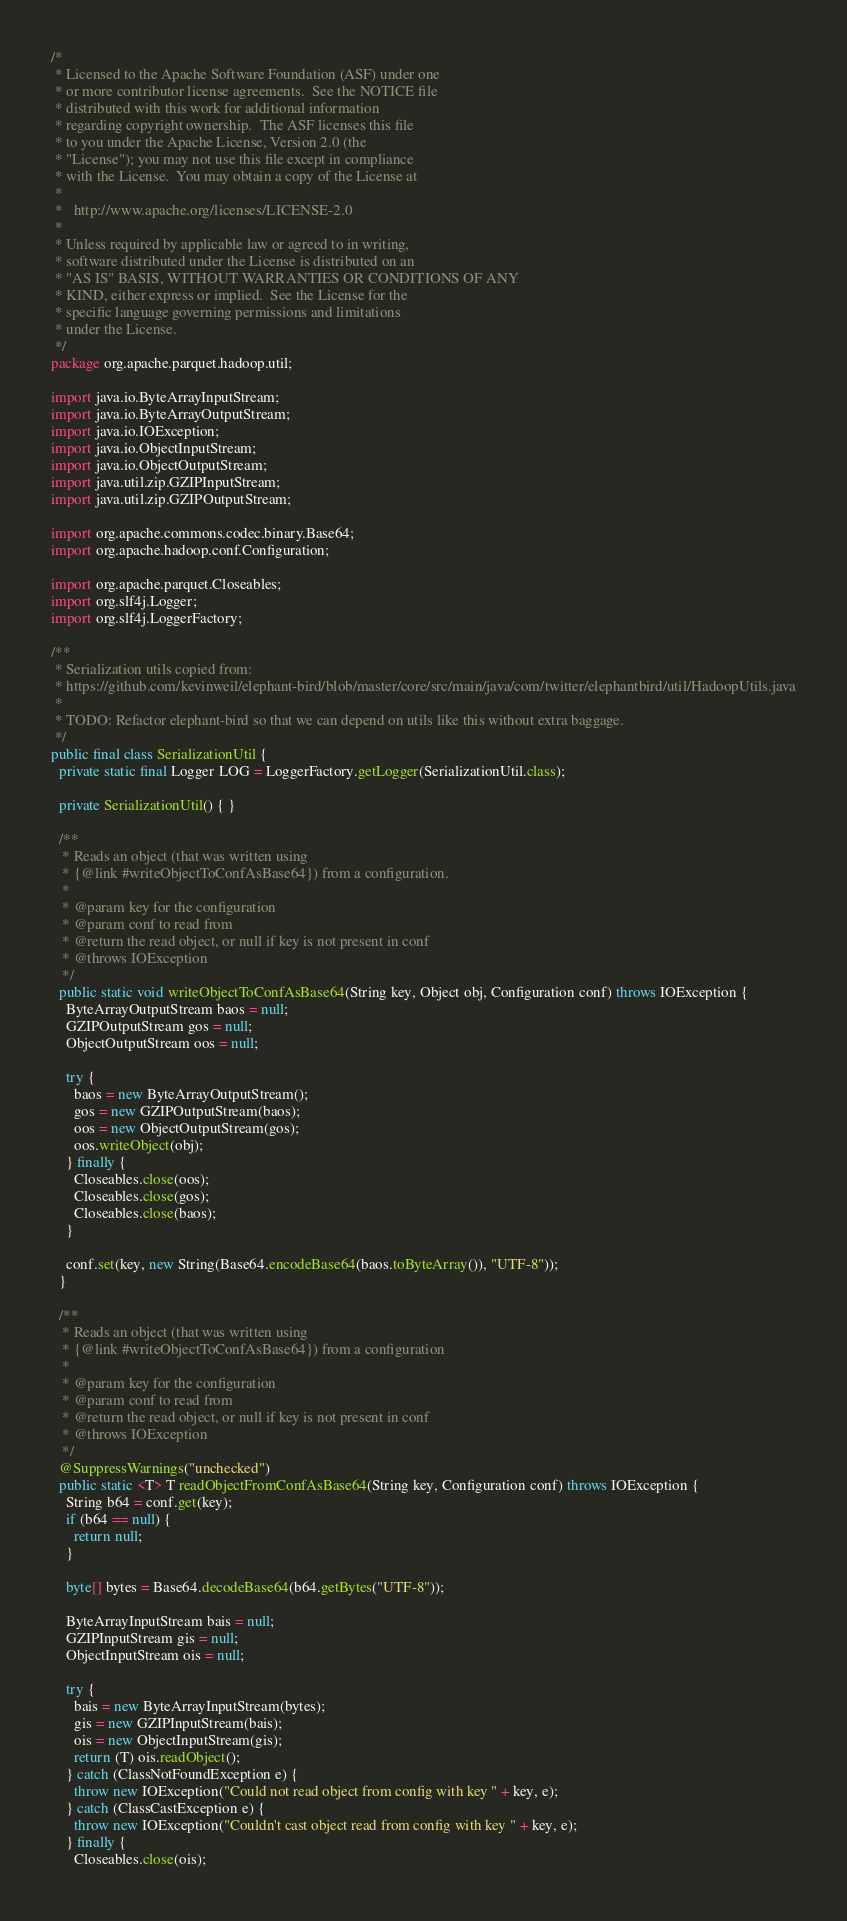Convert code to text. <code><loc_0><loc_0><loc_500><loc_500><_Java_>/* 
 * Licensed to the Apache Software Foundation (ASF) under one
 * or more contributor license agreements.  See the NOTICE file
 * distributed with this work for additional information
 * regarding copyright ownership.  The ASF licenses this file
 * to you under the Apache License, Version 2.0 (the
 * "License"); you may not use this file except in compliance
 * with the License.  You may obtain a copy of the License at
 * 
 *   http://www.apache.org/licenses/LICENSE-2.0
 * 
 * Unless required by applicable law or agreed to in writing,
 * software distributed under the License is distributed on an
 * "AS IS" BASIS, WITHOUT WARRANTIES OR CONDITIONS OF ANY
 * KIND, either express or implied.  See the License for the
 * specific language governing permissions and limitations
 * under the License.
 */
package org.apache.parquet.hadoop.util;

import java.io.ByteArrayInputStream;
import java.io.ByteArrayOutputStream;
import java.io.IOException;
import java.io.ObjectInputStream;
import java.io.ObjectOutputStream;
import java.util.zip.GZIPInputStream;
import java.util.zip.GZIPOutputStream;

import org.apache.commons.codec.binary.Base64;
import org.apache.hadoop.conf.Configuration;

import org.apache.parquet.Closeables;
import org.slf4j.Logger;
import org.slf4j.LoggerFactory;

/**
 * Serialization utils copied from:
 * https://github.com/kevinweil/elephant-bird/blob/master/core/src/main/java/com/twitter/elephantbird/util/HadoopUtils.java
 *
 * TODO: Refactor elephant-bird so that we can depend on utils like this without extra baggage.
 */
public final class SerializationUtil {
  private static final Logger LOG = LoggerFactory.getLogger(SerializationUtil.class);

  private SerializationUtil() { }

  /**
   * Reads an object (that was written using
   * {@link #writeObjectToConfAsBase64}) from a configuration.
   *
   * @param key for the configuration
   * @param conf to read from
   * @return the read object, or null if key is not present in conf
   * @throws IOException
   */
  public static void writeObjectToConfAsBase64(String key, Object obj, Configuration conf) throws IOException {
    ByteArrayOutputStream baos = null;
    GZIPOutputStream gos = null;
    ObjectOutputStream oos = null;

    try {
      baos = new ByteArrayOutputStream();
      gos = new GZIPOutputStream(baos);
      oos = new ObjectOutputStream(gos);
      oos.writeObject(obj);
    } finally {
      Closeables.close(oos);
      Closeables.close(gos);
      Closeables.close(baos);
    }

    conf.set(key, new String(Base64.encodeBase64(baos.toByteArray()), "UTF-8"));
  }

  /**
   * Reads an object (that was written using
   * {@link #writeObjectToConfAsBase64}) from a configuration
   *
   * @param key for the configuration
   * @param conf to read from
   * @return the read object, or null if key is not present in conf
   * @throws IOException
   */
  @SuppressWarnings("unchecked")
  public static <T> T readObjectFromConfAsBase64(String key, Configuration conf) throws IOException {
    String b64 = conf.get(key);
    if (b64 == null) {
      return null;
    }

    byte[] bytes = Base64.decodeBase64(b64.getBytes("UTF-8"));

    ByteArrayInputStream bais = null;
    GZIPInputStream gis = null;
    ObjectInputStream ois = null;

    try {
      bais = new ByteArrayInputStream(bytes);
      gis = new GZIPInputStream(bais);
      ois = new ObjectInputStream(gis);
      return (T) ois.readObject();
    } catch (ClassNotFoundException e) {
      throw new IOException("Could not read object from config with key " + key, e);
    } catch (ClassCastException e) {
      throw new IOException("Couldn't cast object read from config with key " + key, e);
    } finally {
      Closeables.close(ois);</code> 